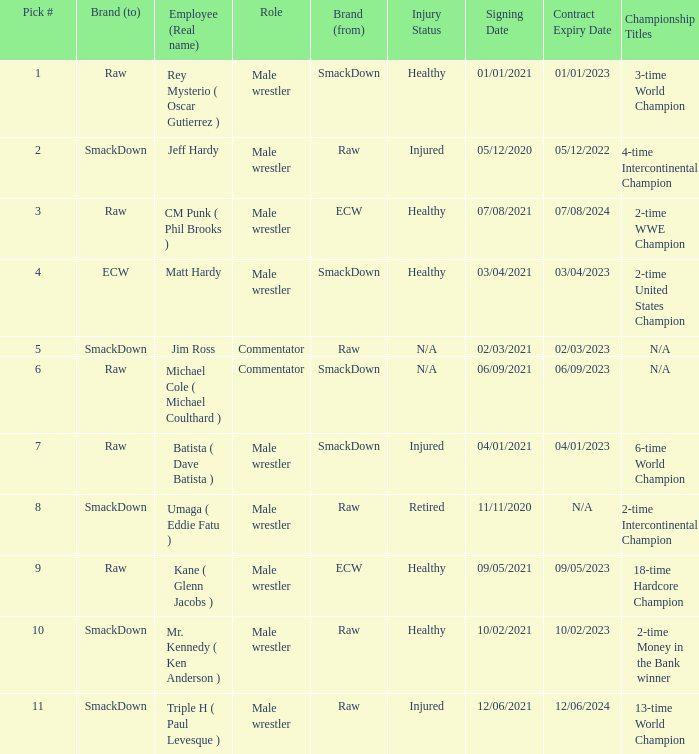What is the real name of the male wrestler from Raw with a pick # smaller than 6? Jeff Hardy. 